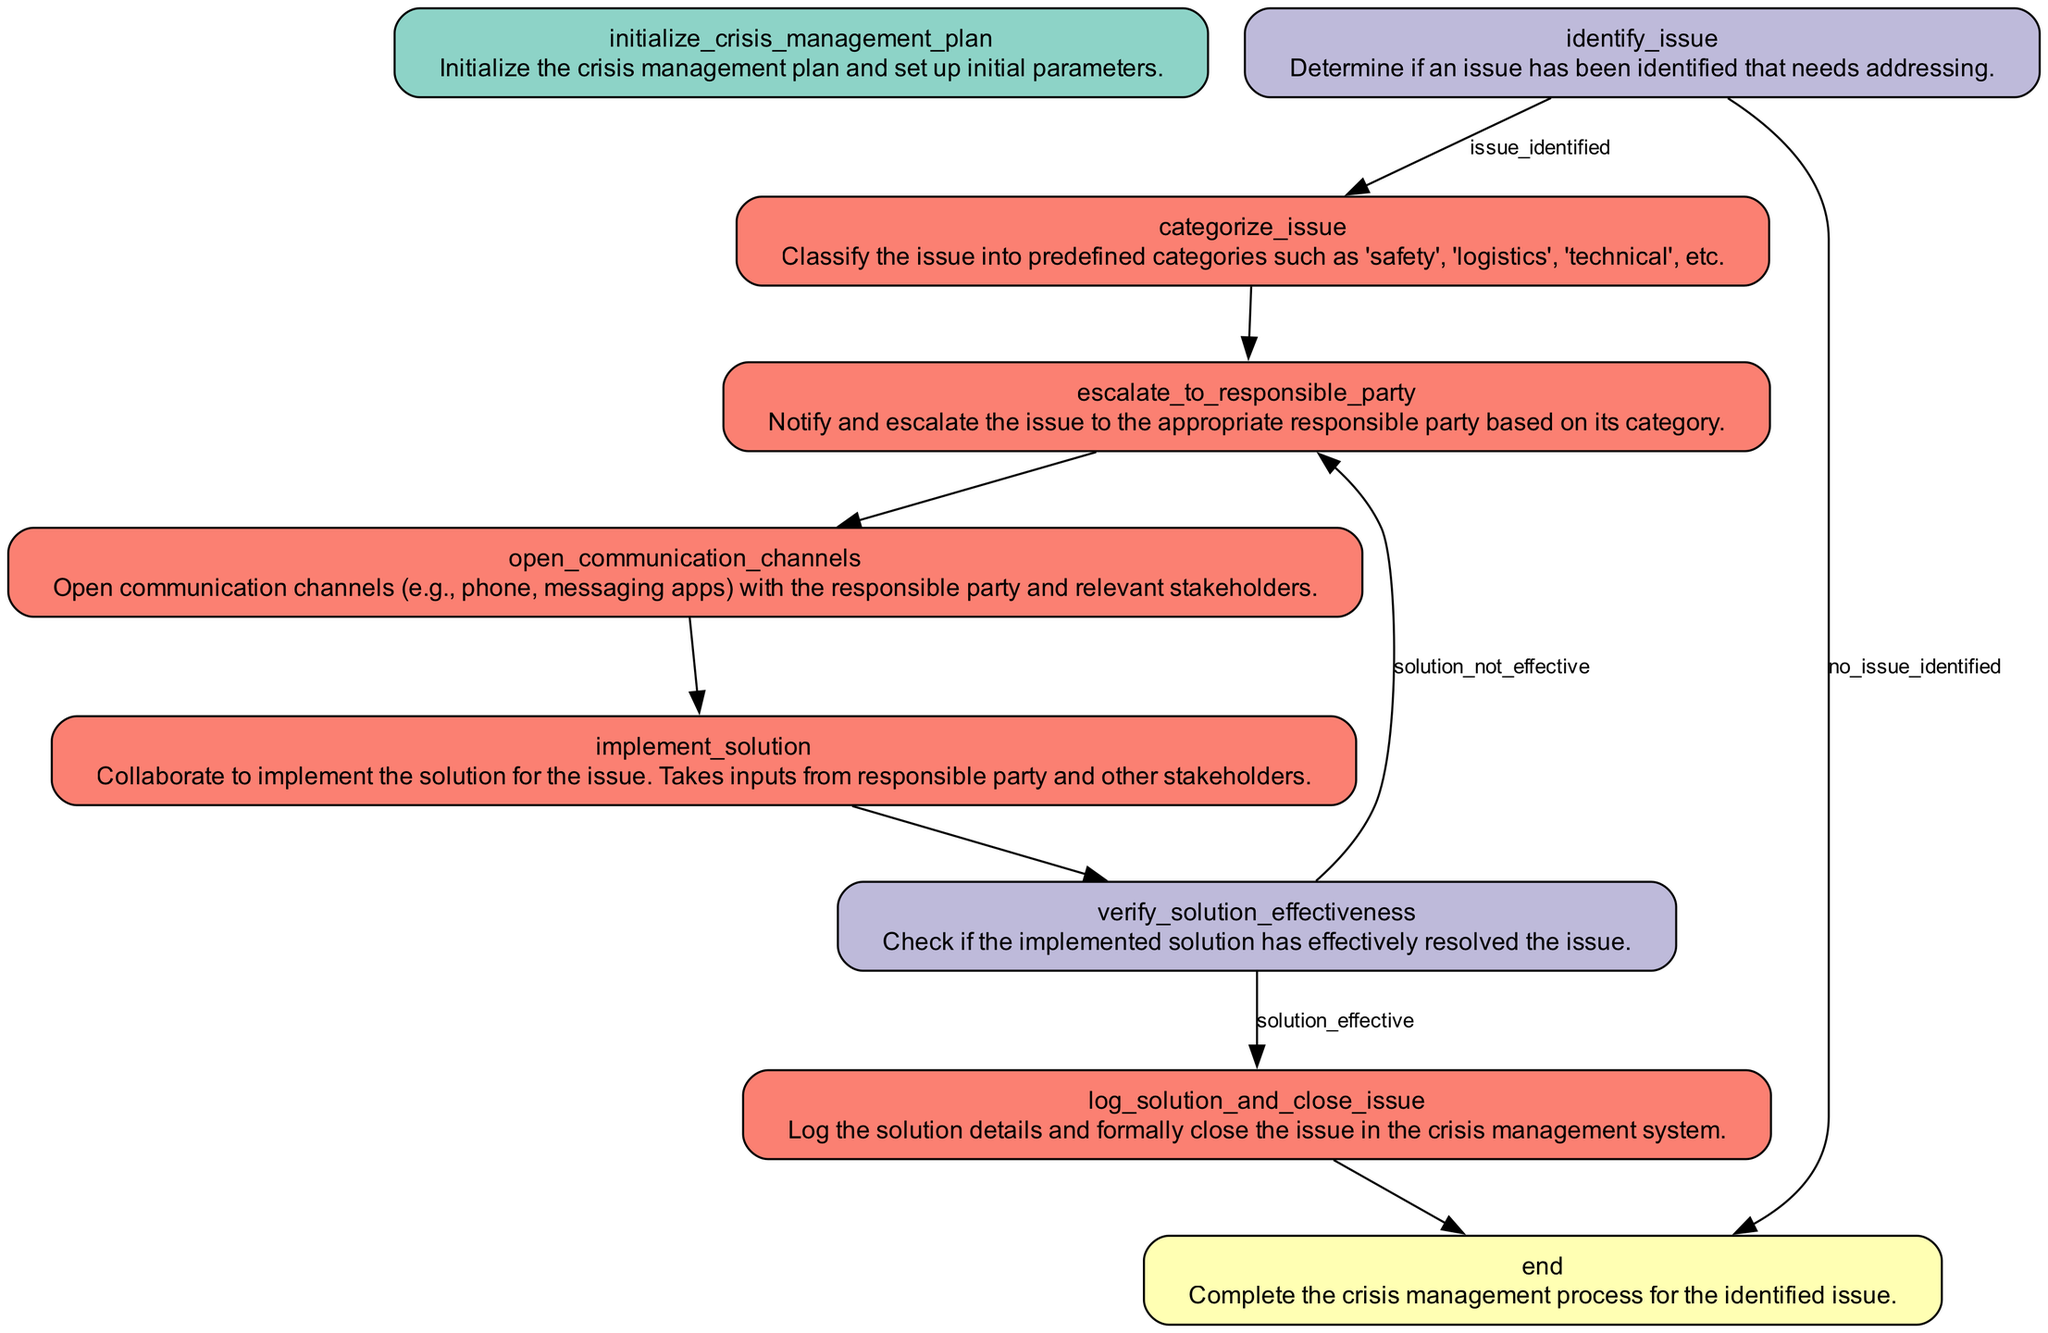What is the first action in the crisis management plan? The first action in the diagram is indicated by the "Start" node, which initializes the crisis management plan and sets up initial parameters.
Answer: Initialize the crisis management plan How many decision nodes are present in the diagram? To determine the number of decision nodes, we can count the nodes with the type "Decision". There are two decision nodes: "identify_issue" and "verify_solution_effectiveness".
Answer: 2 What happens if no issue is identified? If no issue is identified, as indicated by the condition stemming from the "identify_issue" node, the flow goes directly to the "end" node, which concludes the process.
Answer: End What is the consequence of the implemented solution being ineffective? If the implemented solution is not effective, the diagram instructs to escalate the issue back to the responsible party, as indicated from the "verify_solution_effectiveness" node's branches.
Answer: Escalate to responsible party Which action follows the categorization of the issue? After the issue is categorized at the "categorize_issue" node, the next action is to "escalate_to_responsible_party" according to the flow indicated in the diagram.
Answer: Escalate to responsible party In which situation do you log a solution and close the issue? You log a solution and close the issue if the implemented solution is effective, which is shown on the "verify_solution_effectiveness" node where the condition "solution_effective" leads to that action.
Answer: Log solution and close issue What color represents the action nodes in the diagram? The action nodes are represented by the color red (#FB8072) in the diagram, as specified in the color scheme for node types.
Answer: Red How does the diagram indicate starting the crisis management process? The initiation of the process is indicated by the "Start" node, labeled "Initialize the crisis management plan", which is the first element in the flow of the diagram.
Answer: Start 